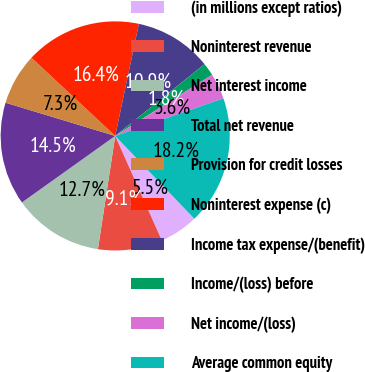Convert chart to OTSL. <chart><loc_0><loc_0><loc_500><loc_500><pie_chart><fcel>(in millions except ratios)<fcel>Noninterest revenue<fcel>Net interest income<fcel>Total net revenue<fcel>Provision for credit losses<fcel>Noninterest expense (c)<fcel>Income tax expense/(benefit)<fcel>Income/(loss) before<fcel>Net income/(loss)<fcel>Average common equity<nl><fcel>5.46%<fcel>9.09%<fcel>12.73%<fcel>14.54%<fcel>7.27%<fcel>16.36%<fcel>10.91%<fcel>1.82%<fcel>3.64%<fcel>18.18%<nl></chart> 